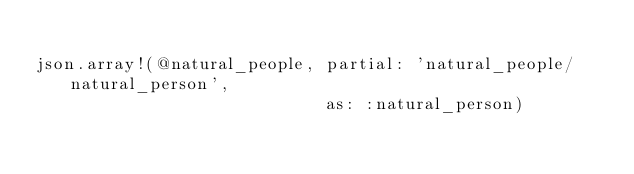<code> <loc_0><loc_0><loc_500><loc_500><_Ruby_>
json.array!(@natural_people, partial: 'natural_people/natural_person',
                             as: :natural_person)
</code> 